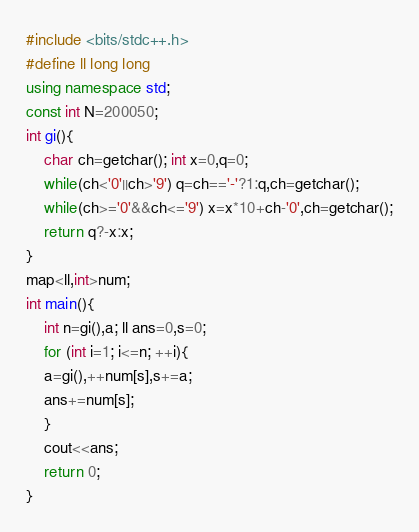<code> <loc_0><loc_0><loc_500><loc_500><_C++_>#include <bits/stdc++.h>
#define ll long long
using namespace std;
const int N=200050;
int gi(){
    char ch=getchar(); int x=0,q=0;
    while(ch<'0'||ch>'9') q=ch=='-'?1:q,ch=getchar();
    while(ch>='0'&&ch<='9') x=x*10+ch-'0',ch=getchar();
    return q?-x:x;
}
map<ll,int>num;
int main(){
    int n=gi(),a; ll ans=0,s=0;
    for (int i=1; i<=n; ++i){
	a=gi(),++num[s],s+=a;
	ans+=num[s];
    }
    cout<<ans;
    return 0;
}
</code> 